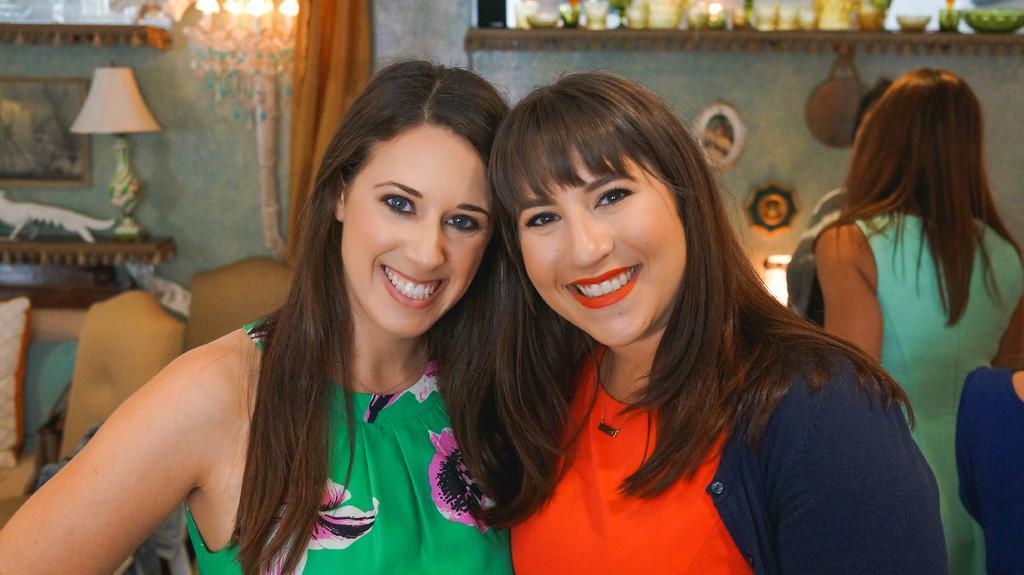Can you describe this image briefly? This image is taken indoors. In the middle of the image there are two women with smiling faces. In the background there is a wall with picture frames and a curtain and there are two lamps. On the left side of the image there is a table with a lamp on it and there are a few empty chairs. On the right side of the image there are a few people. 